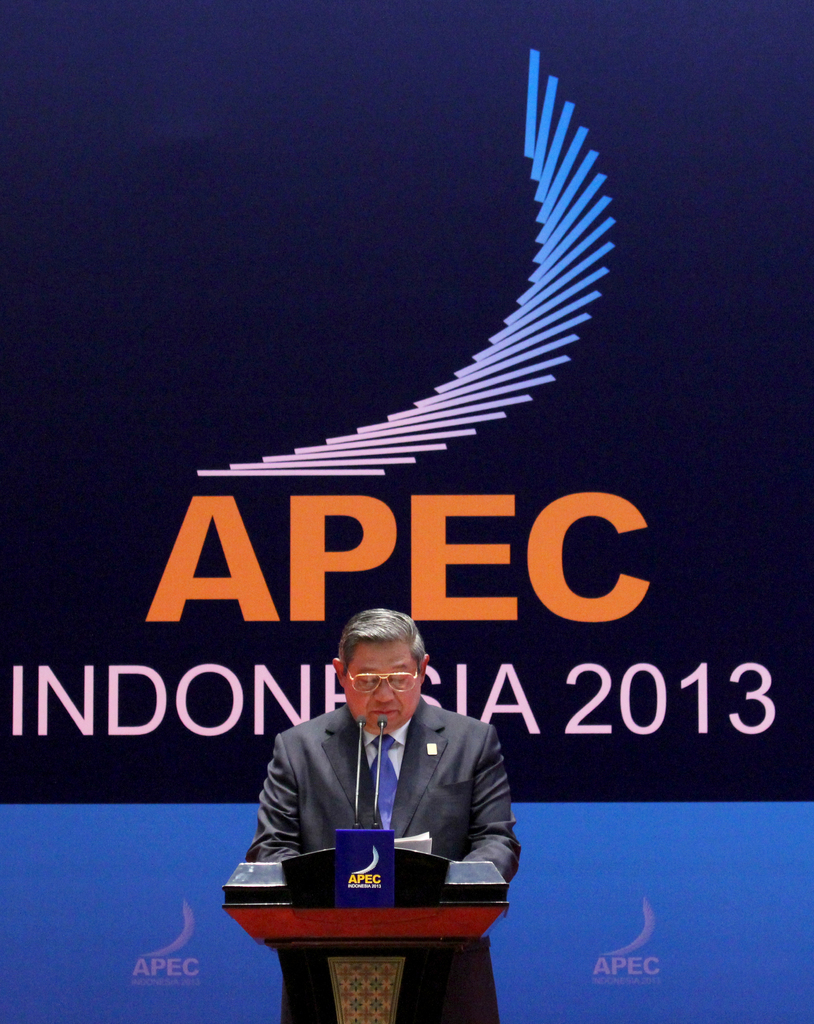Can you tell more about the speaker's role and the context of his speech? The man speaking is likely a key official or leader within APEC, given his central role at the event. He appears to be addressing critical issues related to economic policies or cooperation strategies within the Asia-Pacific region, aiming to foster dialogue and partnerships among member economies. How do events like these influence global economics? Events like APEC conferences are pivotal in shaping global economic policies and ensuring sustainable economic growth. They facilitate discussions on trade agreements, economic barriers, and cooperative strategies that directly impact global markets and investment flows, promoting stability and prosperity in the region. 